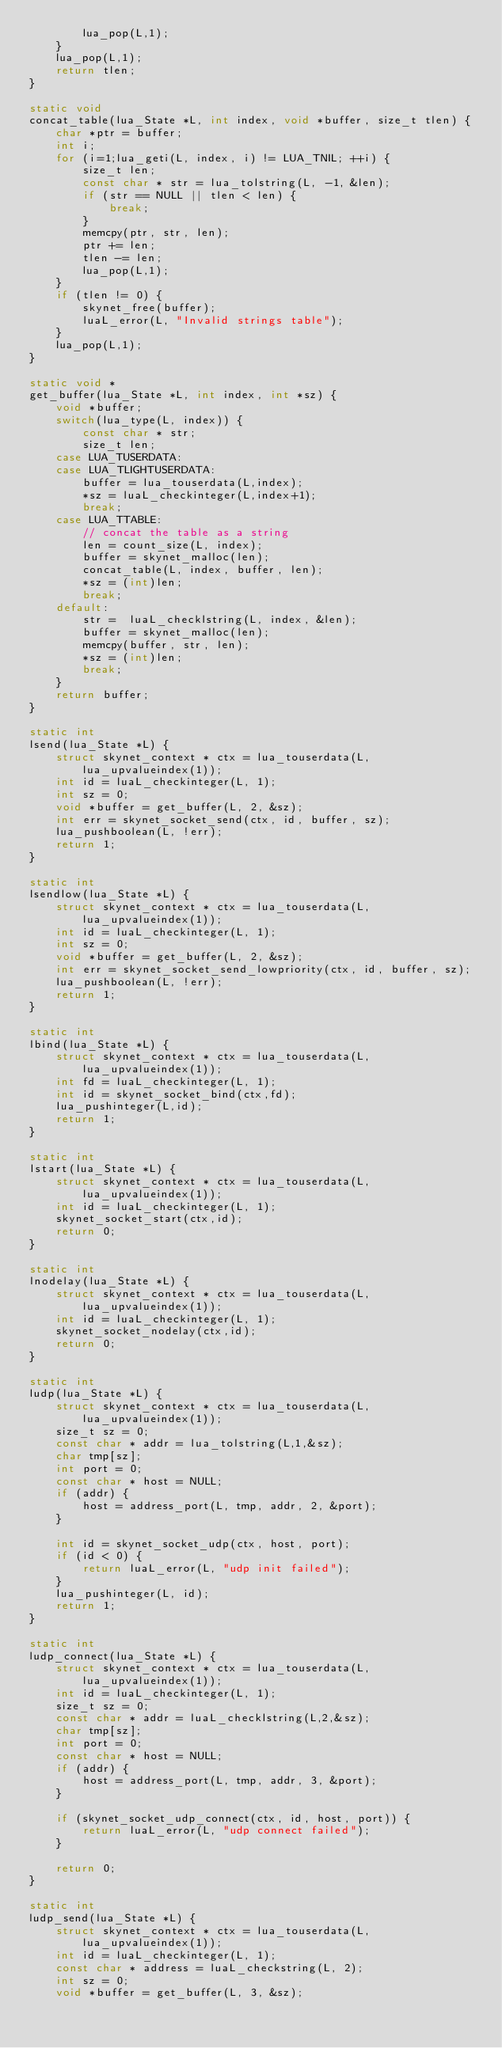<code> <loc_0><loc_0><loc_500><loc_500><_C_>		lua_pop(L,1);
	}
	lua_pop(L,1);
	return tlen;
}

static void
concat_table(lua_State *L, int index, void *buffer, size_t tlen) {
	char *ptr = buffer;
	int i;
	for (i=1;lua_geti(L, index, i) != LUA_TNIL; ++i) {
		size_t len;
		const char * str = lua_tolstring(L, -1, &len);
		if (str == NULL || tlen < len) {
			break;
		}
		memcpy(ptr, str, len);
		ptr += len;
		tlen -= len;
		lua_pop(L,1);
	}
	if (tlen != 0) {
		skynet_free(buffer);
		luaL_error(L, "Invalid strings table");
	}
	lua_pop(L,1);
}

static void *
get_buffer(lua_State *L, int index, int *sz) {
	void *buffer;
	switch(lua_type(L, index)) {
		const char * str;
		size_t len;
	case LUA_TUSERDATA:
	case LUA_TLIGHTUSERDATA:
		buffer = lua_touserdata(L,index);
		*sz = luaL_checkinteger(L,index+1);
		break;
	case LUA_TTABLE:
		// concat the table as a string
		len = count_size(L, index);
		buffer = skynet_malloc(len);
		concat_table(L, index, buffer, len);
		*sz = (int)len;
		break;
	default:
		str =  luaL_checklstring(L, index, &len);
		buffer = skynet_malloc(len);
		memcpy(buffer, str, len);
		*sz = (int)len;
		break;
	}
	return buffer;
}

static int
lsend(lua_State *L) {
	struct skynet_context * ctx = lua_touserdata(L, lua_upvalueindex(1));
	int id = luaL_checkinteger(L, 1);
	int sz = 0;
	void *buffer = get_buffer(L, 2, &sz);
	int err = skynet_socket_send(ctx, id, buffer, sz);
	lua_pushboolean(L, !err);
	return 1;
}

static int
lsendlow(lua_State *L) {
	struct skynet_context * ctx = lua_touserdata(L, lua_upvalueindex(1));
	int id = luaL_checkinteger(L, 1);
	int sz = 0;
	void *buffer = get_buffer(L, 2, &sz);
	int err = skynet_socket_send_lowpriority(ctx, id, buffer, sz);
	lua_pushboolean(L, !err);
	return 1;
}

static int
lbind(lua_State *L) {
	struct skynet_context * ctx = lua_touserdata(L, lua_upvalueindex(1));
	int fd = luaL_checkinteger(L, 1);
	int id = skynet_socket_bind(ctx,fd);
	lua_pushinteger(L,id);
	return 1;
}

static int
lstart(lua_State *L) {
	struct skynet_context * ctx = lua_touserdata(L, lua_upvalueindex(1));
	int id = luaL_checkinteger(L, 1);
	skynet_socket_start(ctx,id);
	return 0;
}

static int
lnodelay(lua_State *L) {
	struct skynet_context * ctx = lua_touserdata(L, lua_upvalueindex(1));
	int id = luaL_checkinteger(L, 1);
	skynet_socket_nodelay(ctx,id);
	return 0;
}

static int
ludp(lua_State *L) {
	struct skynet_context * ctx = lua_touserdata(L, lua_upvalueindex(1));
	size_t sz = 0;
	const char * addr = lua_tolstring(L,1,&sz);
	char tmp[sz];
	int port = 0;
	const char * host = NULL;
	if (addr) {
		host = address_port(L, tmp, addr, 2, &port);
	}

	int id = skynet_socket_udp(ctx, host, port);
	if (id < 0) {
		return luaL_error(L, "udp init failed");
	}
	lua_pushinteger(L, id);
	return 1;
}

static int
ludp_connect(lua_State *L) {
	struct skynet_context * ctx = lua_touserdata(L, lua_upvalueindex(1));
	int id = luaL_checkinteger(L, 1);
	size_t sz = 0;
	const char * addr = luaL_checklstring(L,2,&sz);
	char tmp[sz];
	int port = 0;
	const char * host = NULL;
	if (addr) {
		host = address_port(L, tmp, addr, 3, &port);
	}

	if (skynet_socket_udp_connect(ctx, id, host, port)) {
		return luaL_error(L, "udp connect failed");
	}

	return 0;
}

static int
ludp_send(lua_State *L) {
	struct skynet_context * ctx = lua_touserdata(L, lua_upvalueindex(1));
	int id = luaL_checkinteger(L, 1);
	const char * address = luaL_checkstring(L, 2);
	int sz = 0;
	void *buffer = get_buffer(L, 3, &sz);</code> 